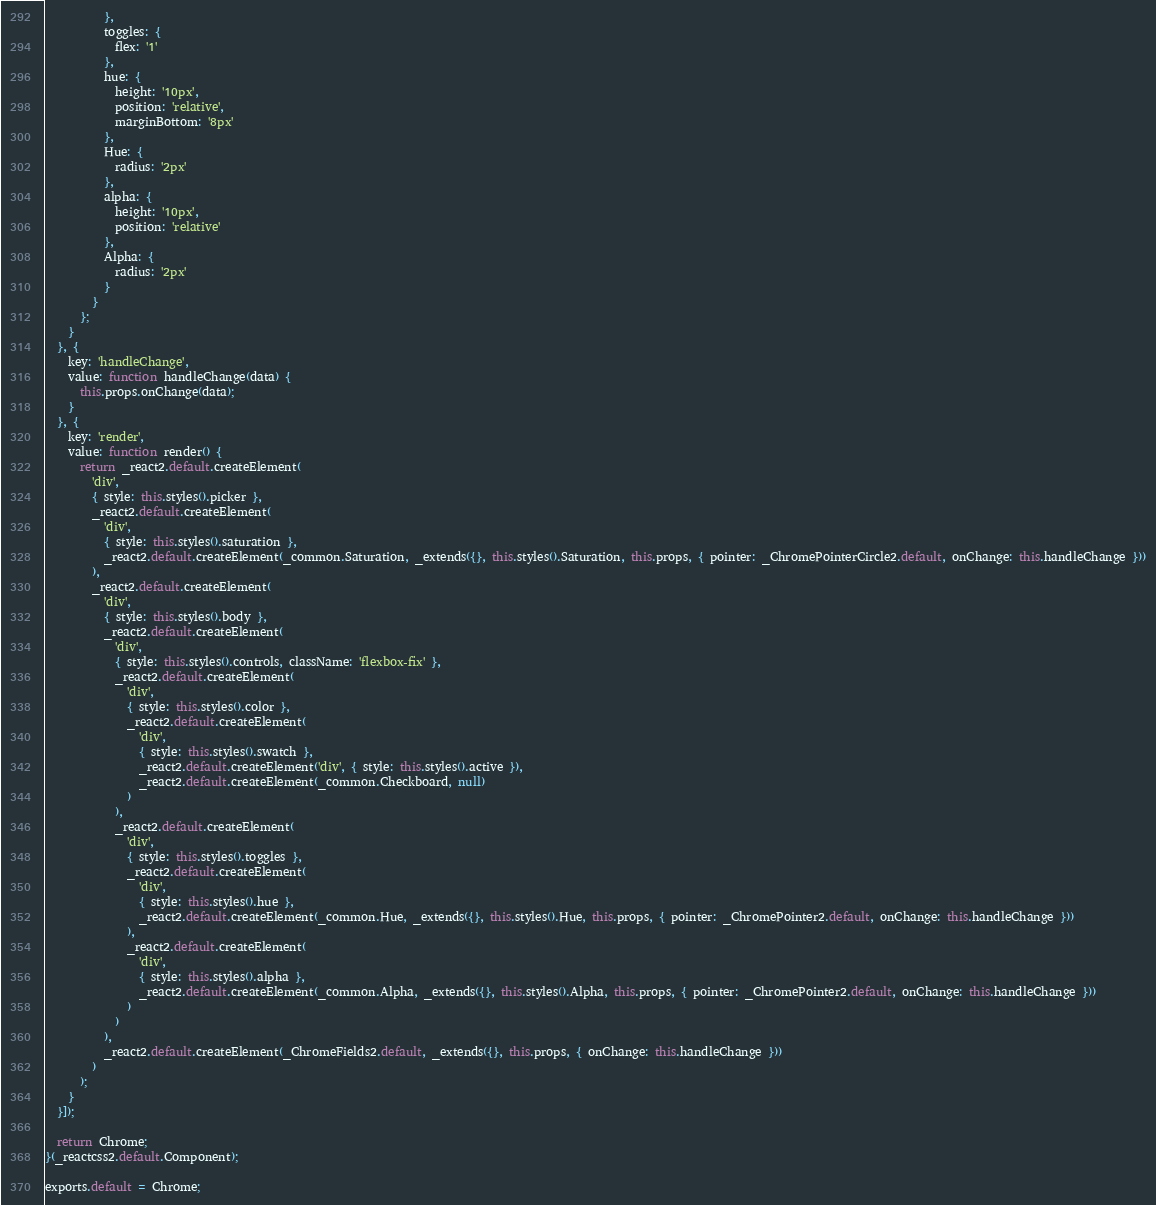Convert code to text. <code><loc_0><loc_0><loc_500><loc_500><_JavaScript_>          },
          toggles: {
            flex: '1'
          },
          hue: {
            height: '10px',
            position: 'relative',
            marginBottom: '8px'
          },
          Hue: {
            radius: '2px'
          },
          alpha: {
            height: '10px',
            position: 'relative'
          },
          Alpha: {
            radius: '2px'
          }
        }
      };
    }
  }, {
    key: 'handleChange',
    value: function handleChange(data) {
      this.props.onChange(data);
    }
  }, {
    key: 'render',
    value: function render() {
      return _react2.default.createElement(
        'div',
        { style: this.styles().picker },
        _react2.default.createElement(
          'div',
          { style: this.styles().saturation },
          _react2.default.createElement(_common.Saturation, _extends({}, this.styles().Saturation, this.props, { pointer: _ChromePointerCircle2.default, onChange: this.handleChange }))
        ),
        _react2.default.createElement(
          'div',
          { style: this.styles().body },
          _react2.default.createElement(
            'div',
            { style: this.styles().controls, className: 'flexbox-fix' },
            _react2.default.createElement(
              'div',
              { style: this.styles().color },
              _react2.default.createElement(
                'div',
                { style: this.styles().swatch },
                _react2.default.createElement('div', { style: this.styles().active }),
                _react2.default.createElement(_common.Checkboard, null)
              )
            ),
            _react2.default.createElement(
              'div',
              { style: this.styles().toggles },
              _react2.default.createElement(
                'div',
                { style: this.styles().hue },
                _react2.default.createElement(_common.Hue, _extends({}, this.styles().Hue, this.props, { pointer: _ChromePointer2.default, onChange: this.handleChange }))
              ),
              _react2.default.createElement(
                'div',
                { style: this.styles().alpha },
                _react2.default.createElement(_common.Alpha, _extends({}, this.styles().Alpha, this.props, { pointer: _ChromePointer2.default, onChange: this.handleChange }))
              )
            )
          ),
          _react2.default.createElement(_ChromeFields2.default, _extends({}, this.props, { onChange: this.handleChange }))
        )
      );
    }
  }]);

  return Chrome;
}(_reactcss2.default.Component);

exports.default = Chrome;</code> 